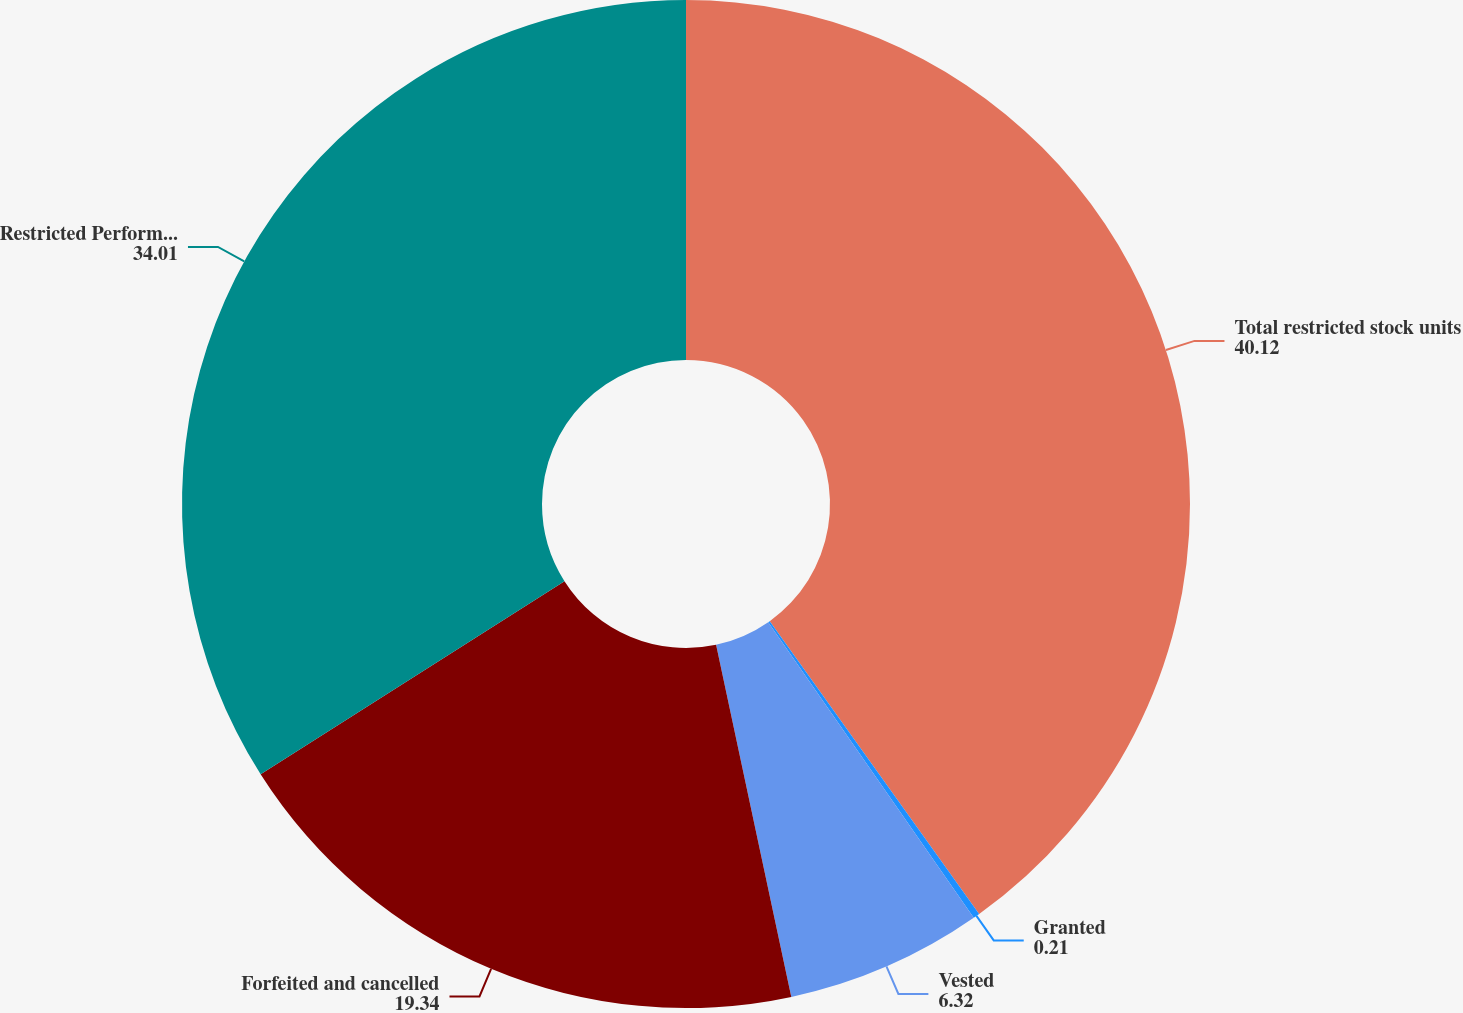Convert chart to OTSL. <chart><loc_0><loc_0><loc_500><loc_500><pie_chart><fcel>Total restricted stock units<fcel>Granted<fcel>Vested<fcel>Forfeited and cancelled<fcel>Restricted Performance Units<nl><fcel>40.12%<fcel>0.21%<fcel>6.32%<fcel>19.34%<fcel>34.01%<nl></chart> 